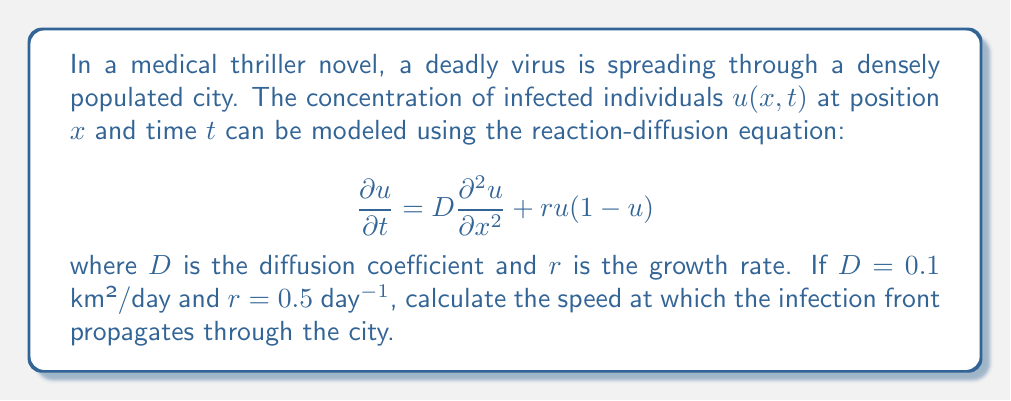What is the answer to this math problem? To solve this problem, we'll use the Fisher-KPP equation, which is a special case of the reaction-diffusion equation given in the question. The speed of propagation for the infection front can be determined using the following steps:

1. The Fisher-KPP equation has the form:
   $$\frac{\partial u}{\partial t} = D\frac{\partial^2 u}{\partial x^2} + ru(1-u)$$

2. For this equation, it's known that the speed of the traveling wave solution (which represents the infection front) is given by:
   $$c = 2\sqrt{Dr}$$

3. We are given:
   $D = 0.1$ km²/day (diffusion coefficient)
   $r = 0.5$ day⁻¹ (growth rate)

4. Substituting these values into the speed formula:
   $$c = 2\sqrt{(0.1)(0.5)}$$

5. Simplifying:
   $$c = 2\sqrt{0.05}$$
   $$c = 2(0.2236)$$
   $$c = 0.4472$$ km/day

6. Rounding to three decimal places:
   $$c \approx 0.447$$ km/day

This result indicates that the infection front will propagate through the city at a speed of approximately 0.447 km per day, providing a scientifically accurate detail that adds authenticity to the medical thriller scenario.
Answer: The speed at which the infection front propagates through the city is approximately 0.447 km/day. 